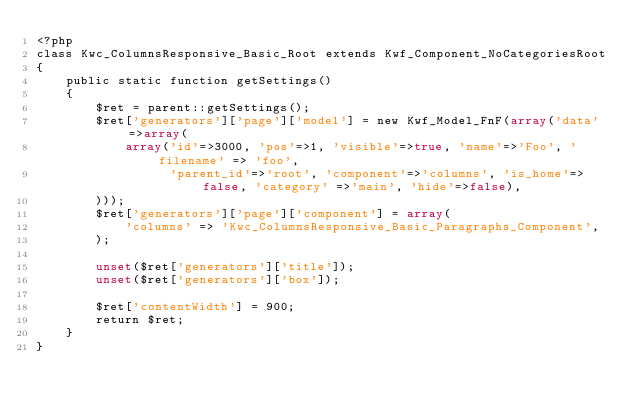Convert code to text. <code><loc_0><loc_0><loc_500><loc_500><_PHP_><?php
class Kwc_ColumnsResponsive_Basic_Root extends Kwf_Component_NoCategoriesRoot
{
    public static function getSettings()
    {
        $ret = parent::getSettings();
        $ret['generators']['page']['model'] = new Kwf_Model_FnF(array('data'=>array(
            array('id'=>3000, 'pos'=>1, 'visible'=>true, 'name'=>'Foo', 'filename' => 'foo',
                  'parent_id'=>'root', 'component'=>'columns', 'is_home'=>false, 'category' =>'main', 'hide'=>false),
        )));
        $ret['generators']['page']['component'] = array(
            'columns' => 'Kwc_ColumnsResponsive_Basic_Paragraphs_Component',
        );

        unset($ret['generators']['title']);
        unset($ret['generators']['box']);

        $ret['contentWidth'] = 900;
        return $ret;
    }
}
</code> 